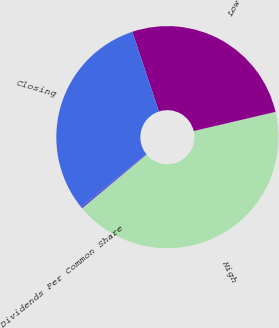Convert chart. <chart><loc_0><loc_0><loc_500><loc_500><pie_chart><fcel>High<fcel>Low<fcel>Closing<fcel>Dividends Per Common Share<nl><fcel>42.58%<fcel>26.46%<fcel>30.7%<fcel>0.26%<nl></chart> 